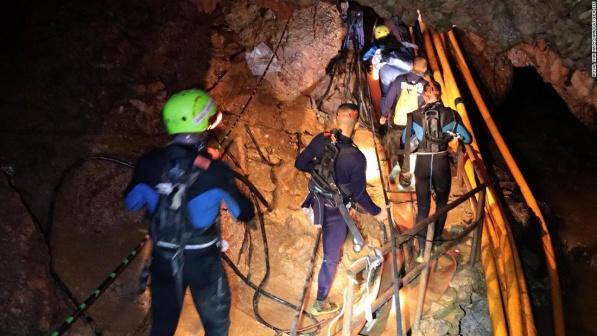Describe the feelings or emotions of the adventurers as they navigate through the cave. The adventurers likely experience a mix of excitement and apprehension as they delve into the cave's depths. The exhilaration of discovery and the thrill of exploring uncharted territory are palpable. Simultaneously, a sense of caution and focus pervades their actions. Their meticulous movements and reliance on ropes and headlamps suggest a careful navigation through potential dangers. The camaraderie among the group offers reassurance and boosts their morale as they tackle the challenges ahead, embodied in trust and teamwork formed through shared adventure. 